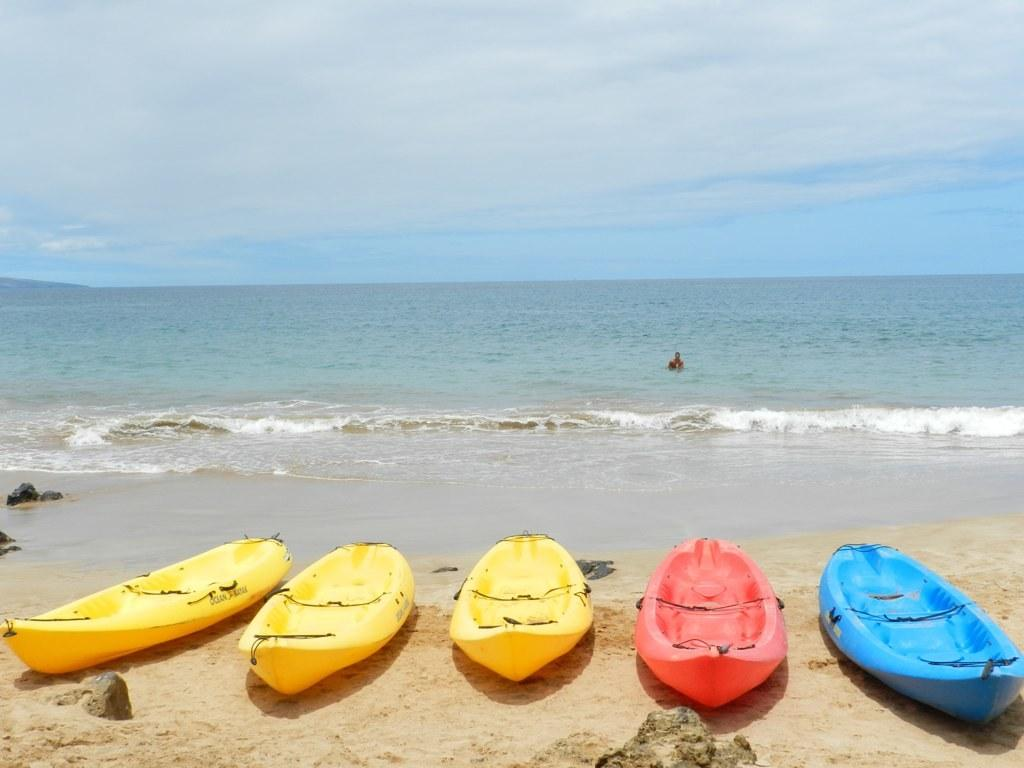How many boats are on the sand in the image? There are five boats on the sand in the image. What else can be seen in the background of the image? There is a person in the water in the background. What type of natural elements are present on the left side of the image? There are stones on the sand on the left side. What is visible in the sky in the image? Clouds are visible in the sky. What is the level of protest in the image? There is no protest present in the image; it features boats on the sand, a person in the water, stones on the sand, and clouds in the sky. Is there a battle taking place in the image? There is no battle present in the image; it features boats on the sand, a person in the water, stones on the sand, and clouds in the sky. 